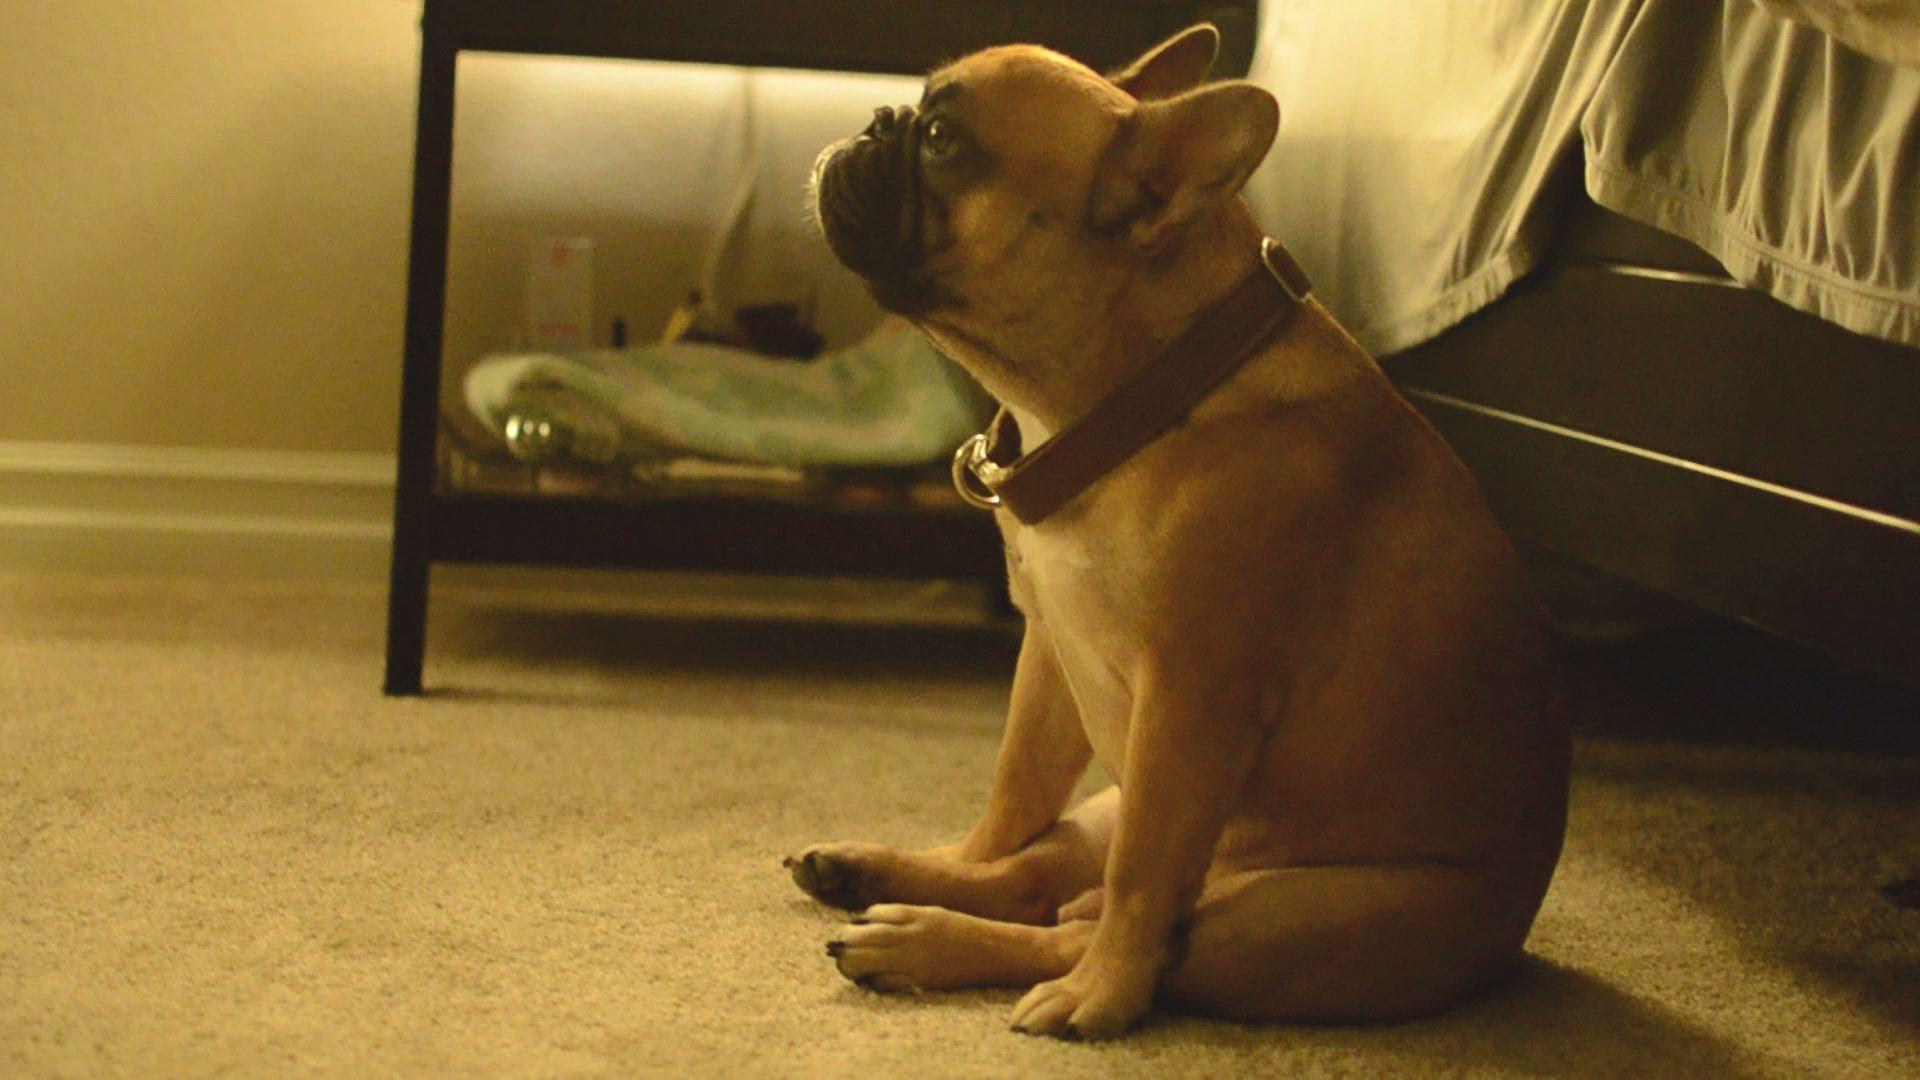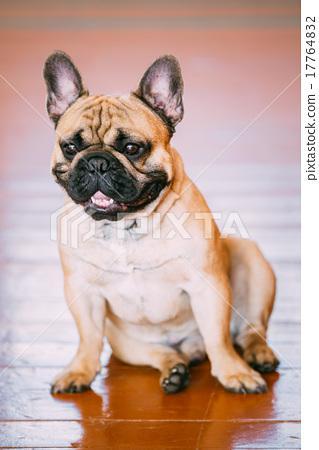The first image is the image on the left, the second image is the image on the right. Analyze the images presented: Is the assertion "One dog is indoors, and another is outdoors." valid? Answer yes or no. No. 